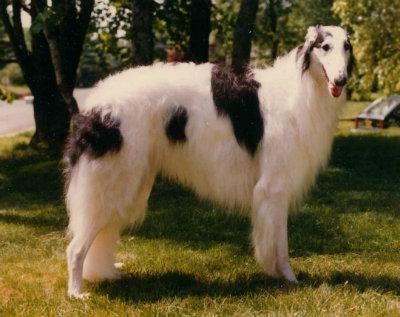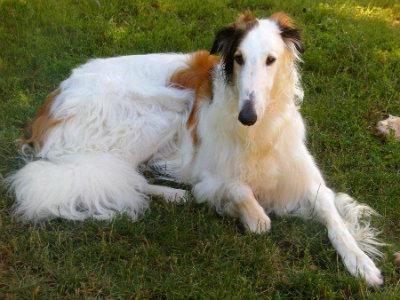The first image is the image on the left, the second image is the image on the right. Analyze the images presented: Is the assertion "Right image shows exactly one black and white hound in profile." valid? Answer yes or no. No. 